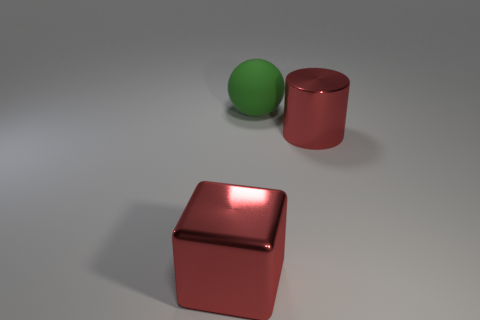What color is the big thing that is in front of the red metallic cylinder?
Provide a succinct answer. Red. What number of things are large cubes or cyan cylinders?
Give a very brief answer. 1. There is a big red object that is in front of the red cylinder in front of the large green rubber ball; what is it made of?
Give a very brief answer. Metal. Are there any big cylinders that have the same color as the metal block?
Give a very brief answer. Yes. How many things are either metallic objects behind the large red block or metal things that are on the left side of the big green object?
Keep it short and to the point. 2. Are there any shiny things that are to the left of the object behind the shiny cylinder?
Keep it short and to the point. Yes. What shape is the red object that is the same size as the metallic cube?
Offer a very short reply. Cylinder. How many objects are either big red things behind the red metallic block or big brown shiny objects?
Provide a succinct answer. 1. How many other objects are the same material as the block?
Make the answer very short. 1. What shape is the thing that is the same color as the cube?
Keep it short and to the point. Cylinder. 